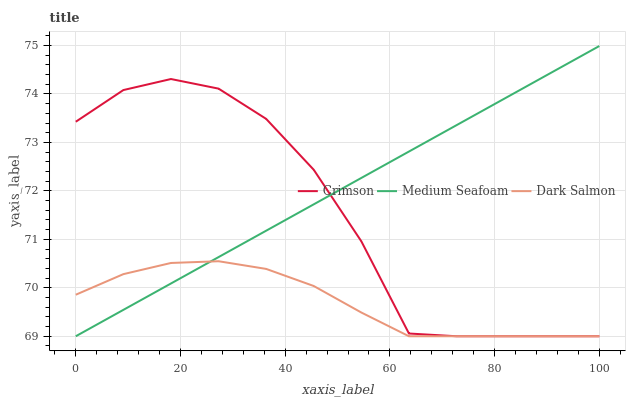Does Medium Seafoam have the minimum area under the curve?
Answer yes or no. No. Does Dark Salmon have the maximum area under the curve?
Answer yes or no. No. Is Dark Salmon the smoothest?
Answer yes or no. No. Is Dark Salmon the roughest?
Answer yes or no. No. Does Dark Salmon have the highest value?
Answer yes or no. No. 